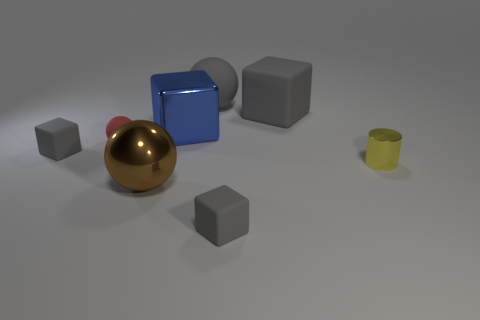Subtract all gray blocks. How many were subtracted if there are1gray blocks left? 2 Subtract all green cylinders. How many gray cubes are left? 3 Subtract 1 blocks. How many blocks are left? 3 Subtract all gray blocks. How many blocks are left? 1 Subtract all blue cubes. How many cubes are left? 3 Add 2 small yellow matte things. How many objects exist? 10 Subtract all red blocks. Subtract all blue cylinders. How many blocks are left? 4 Subtract 0 blue cylinders. How many objects are left? 8 Subtract all balls. How many objects are left? 5 Subtract all blue objects. Subtract all big brown shiny things. How many objects are left? 6 